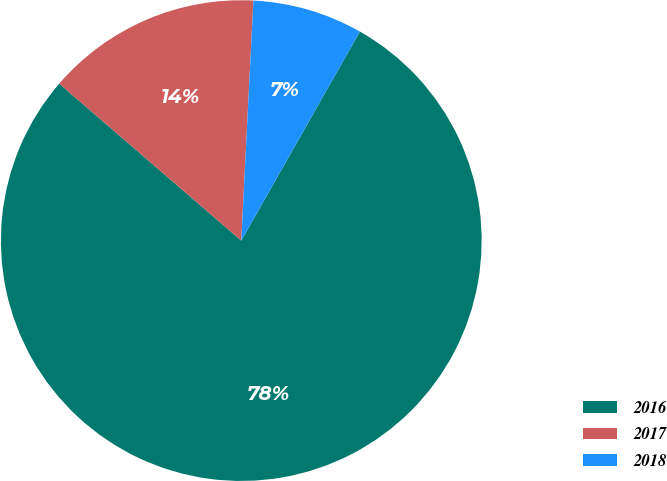Convert chart to OTSL. <chart><loc_0><loc_0><loc_500><loc_500><pie_chart><fcel>2016<fcel>2017<fcel>2018<nl><fcel>78.11%<fcel>14.48%<fcel>7.41%<nl></chart> 